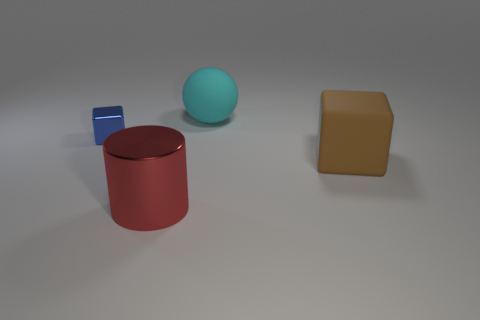Add 3 cubes. How many objects exist? 7 Subtract all blue cubes. How many cubes are left? 1 Subtract all cylinders. How many objects are left? 3 Subtract all brown balls. How many brown blocks are left? 1 Subtract all small green metal spheres. Subtract all tiny metal things. How many objects are left? 3 Add 1 large cyan matte balls. How many large cyan matte balls are left? 2 Add 4 big brown matte things. How many big brown matte things exist? 5 Subtract 1 red cylinders. How many objects are left? 3 Subtract all red cubes. Subtract all cyan balls. How many cubes are left? 2 